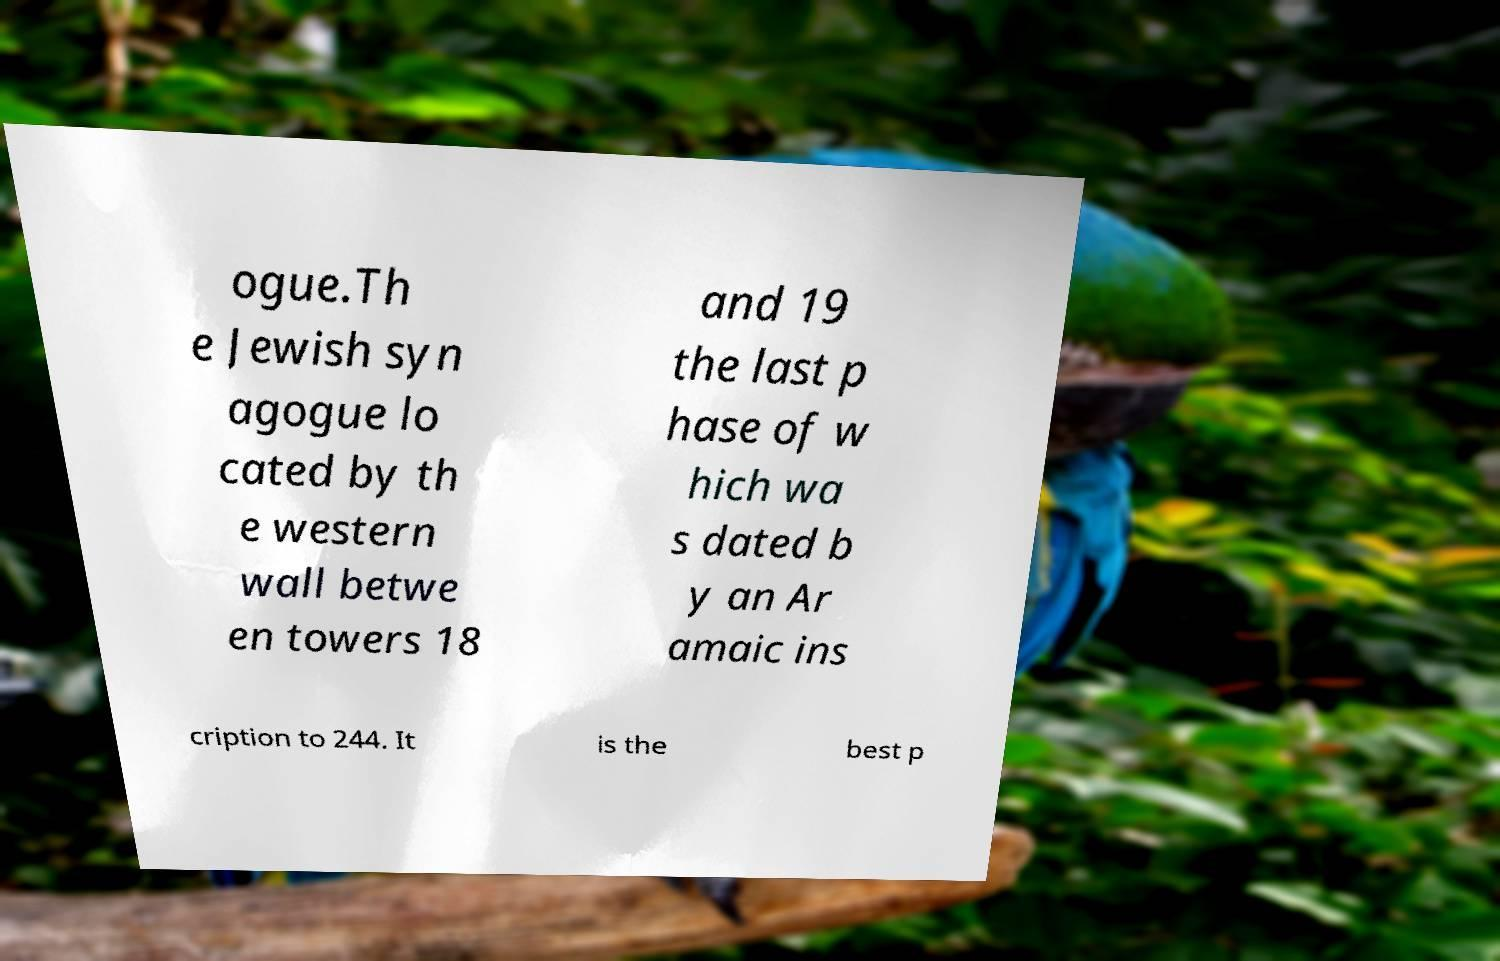Could you extract and type out the text from this image? ogue.Th e Jewish syn agogue lo cated by th e western wall betwe en towers 18 and 19 the last p hase of w hich wa s dated b y an Ar amaic ins cription to 244. It is the best p 